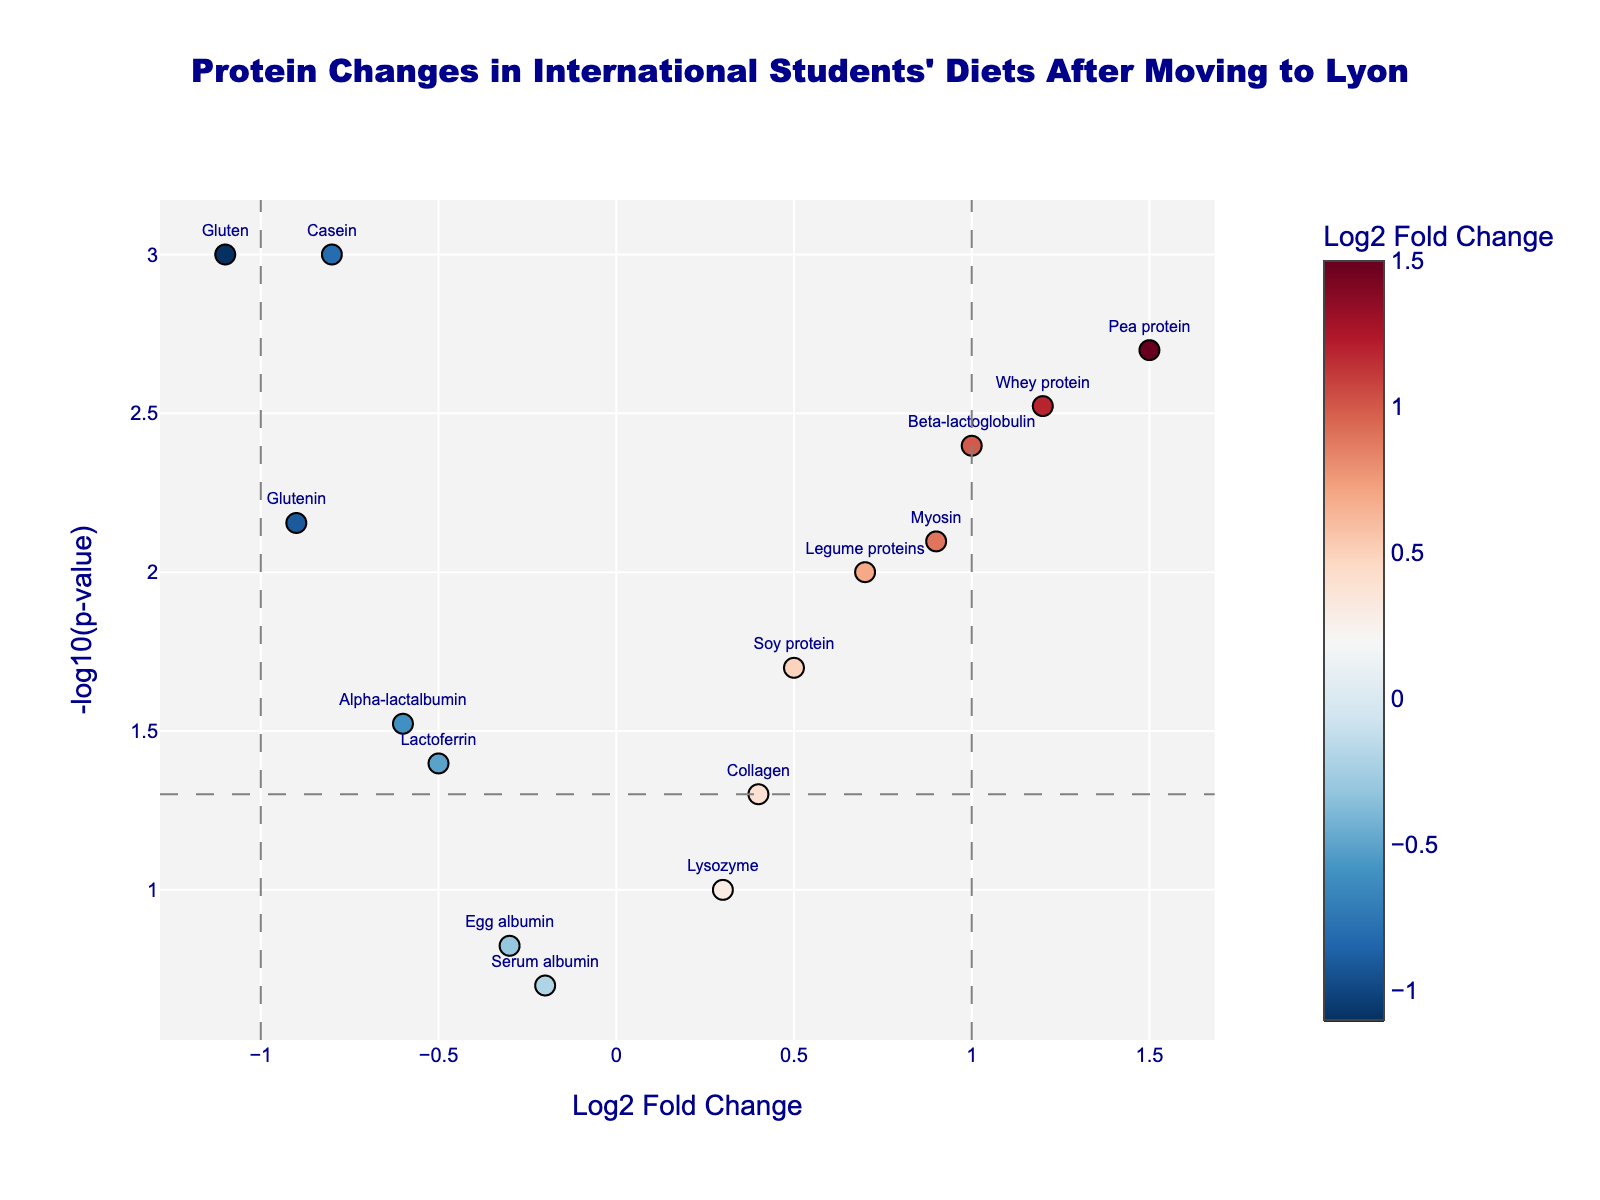Which protein shows the greatest positive Log2FoldChange? The protein with the greatest positive Log2FoldChange is the one farthest to the right on the x-axis. This is the Pea protein.
Answer: Pea protein Which protein has the most significant p-value? The protein with the most significant p-value will have the highest -log10(p-value) on the y-axis. This is Casein, with a -log10(p-value) > 3.
Answer: Casein What is the Log2FoldChange threshold for significant changes? The threshold lines for significant Log2FoldChange are at x = -1 and x = 1, as shown by the vertical dashed lines.
Answer: -1 and 1 Which proteins are considered differentially expressed based on the p-value threshold of 0.05? Proteins with -log10(p-value) > 1.3 are considered significant (p-value < 0.05). The proteins Casein, Whey protein, Pea protein, Myosin, Beta-lactoglobulin, Gluten, and Glutenin meet this criterion.
Answer: Casein, Whey protein, Pea protein, Myosin, Beta-lactoglobulin, Gluten, Glutenin How does the Log2FoldChange of Soy protein compare to that of Egg albumin? Soy protein has a Log2FoldChange of 0.5, while Egg albumin has a Log2FoldChange of -0.3. Therefore, Soy protein has a higher Log2FoldChange than Egg albumin.
Answer: Soy protein has a higher Log2FoldChange Among proteins with a negative Log2FoldChange, which one shows the most significant change? Among proteins with negative Log2FoldChange values, the one with the highest -log10(p-value) is Gluten, making it the most significant.
Answer: Gluten What are the axis titles of the volcano plot? The x-axis title is "Log2 Fold Change", and the y-axis title is "-log10(p-value)".
Answer: "Log2 Fold Change" and "-log10(p-value)" What does it mean if a protein's name is positioned higher on the y-axis? If a protein's name is positioned higher on the y-axis, it means it has a more significant p-value (lower p-value, higher -log10(p-value)).
Answer: More significant p-value Which protein has the least significant change, and what is its p-value? Serum albumin has the least significant change, located at lower positions on the y-axis. Its p-value is 0.2.
Answer: Serum albumin, 0.2 